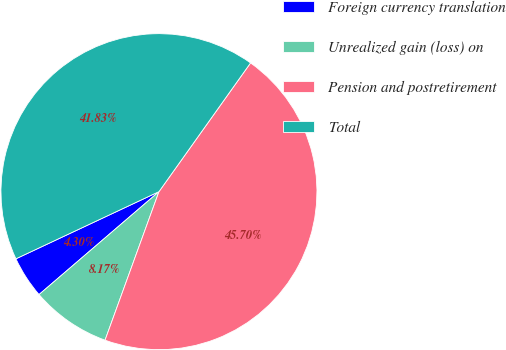Convert chart to OTSL. <chart><loc_0><loc_0><loc_500><loc_500><pie_chart><fcel>Foreign currency translation<fcel>Unrealized gain (loss) on<fcel>Pension and postretirement<fcel>Total<nl><fcel>4.3%<fcel>8.17%<fcel>45.7%<fcel>41.83%<nl></chart> 